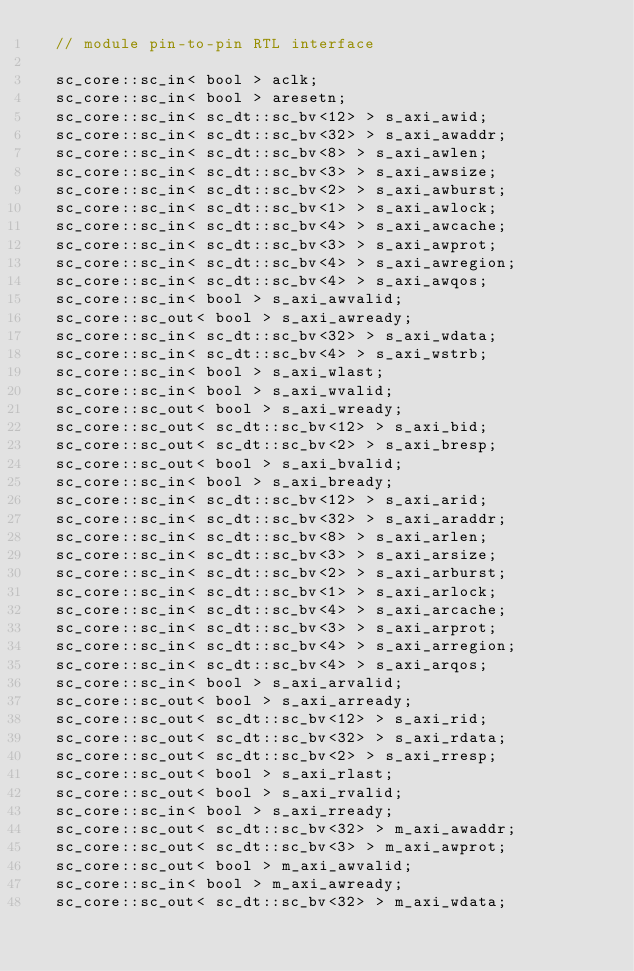Convert code to text. <code><loc_0><loc_0><loc_500><loc_500><_C_>  // module pin-to-pin RTL interface

  sc_core::sc_in< bool > aclk;
  sc_core::sc_in< bool > aresetn;
  sc_core::sc_in< sc_dt::sc_bv<12> > s_axi_awid;
  sc_core::sc_in< sc_dt::sc_bv<32> > s_axi_awaddr;
  sc_core::sc_in< sc_dt::sc_bv<8> > s_axi_awlen;
  sc_core::sc_in< sc_dt::sc_bv<3> > s_axi_awsize;
  sc_core::sc_in< sc_dt::sc_bv<2> > s_axi_awburst;
  sc_core::sc_in< sc_dt::sc_bv<1> > s_axi_awlock;
  sc_core::sc_in< sc_dt::sc_bv<4> > s_axi_awcache;
  sc_core::sc_in< sc_dt::sc_bv<3> > s_axi_awprot;
  sc_core::sc_in< sc_dt::sc_bv<4> > s_axi_awregion;
  sc_core::sc_in< sc_dt::sc_bv<4> > s_axi_awqos;
  sc_core::sc_in< bool > s_axi_awvalid;
  sc_core::sc_out< bool > s_axi_awready;
  sc_core::sc_in< sc_dt::sc_bv<32> > s_axi_wdata;
  sc_core::sc_in< sc_dt::sc_bv<4> > s_axi_wstrb;
  sc_core::sc_in< bool > s_axi_wlast;
  sc_core::sc_in< bool > s_axi_wvalid;
  sc_core::sc_out< bool > s_axi_wready;
  sc_core::sc_out< sc_dt::sc_bv<12> > s_axi_bid;
  sc_core::sc_out< sc_dt::sc_bv<2> > s_axi_bresp;
  sc_core::sc_out< bool > s_axi_bvalid;
  sc_core::sc_in< bool > s_axi_bready;
  sc_core::sc_in< sc_dt::sc_bv<12> > s_axi_arid;
  sc_core::sc_in< sc_dt::sc_bv<32> > s_axi_araddr;
  sc_core::sc_in< sc_dt::sc_bv<8> > s_axi_arlen;
  sc_core::sc_in< sc_dt::sc_bv<3> > s_axi_arsize;
  sc_core::sc_in< sc_dt::sc_bv<2> > s_axi_arburst;
  sc_core::sc_in< sc_dt::sc_bv<1> > s_axi_arlock;
  sc_core::sc_in< sc_dt::sc_bv<4> > s_axi_arcache;
  sc_core::sc_in< sc_dt::sc_bv<3> > s_axi_arprot;
  sc_core::sc_in< sc_dt::sc_bv<4> > s_axi_arregion;
  sc_core::sc_in< sc_dt::sc_bv<4> > s_axi_arqos;
  sc_core::sc_in< bool > s_axi_arvalid;
  sc_core::sc_out< bool > s_axi_arready;
  sc_core::sc_out< sc_dt::sc_bv<12> > s_axi_rid;
  sc_core::sc_out< sc_dt::sc_bv<32> > s_axi_rdata;
  sc_core::sc_out< sc_dt::sc_bv<2> > s_axi_rresp;
  sc_core::sc_out< bool > s_axi_rlast;
  sc_core::sc_out< bool > s_axi_rvalid;
  sc_core::sc_in< bool > s_axi_rready;
  sc_core::sc_out< sc_dt::sc_bv<32> > m_axi_awaddr;
  sc_core::sc_out< sc_dt::sc_bv<3> > m_axi_awprot;
  sc_core::sc_out< bool > m_axi_awvalid;
  sc_core::sc_in< bool > m_axi_awready;
  sc_core::sc_out< sc_dt::sc_bv<32> > m_axi_wdata;</code> 